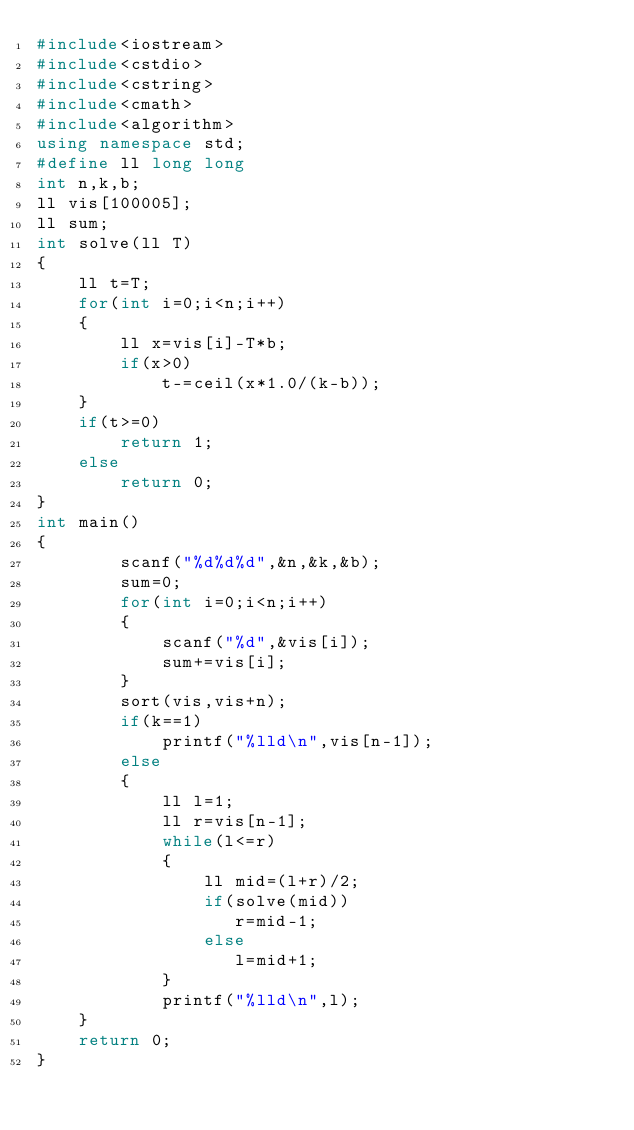Convert code to text. <code><loc_0><loc_0><loc_500><loc_500><_C++_>#include<iostream>
#include<cstdio>
#include<cstring>
#include<cmath>
#include<algorithm>
using namespace std;
#define ll long long
int n,k,b;
ll vis[100005];
ll sum;
int solve(ll T)
{
    ll t=T;
    for(int i=0;i<n;i++)
    {
        ll x=vis[i]-T*b;
        if(x>0)
            t-=ceil(x*1.0/(k-b));
    }
    if(t>=0)
        return 1;
    else
        return 0;
}
int main()
{
        scanf("%d%d%d",&n,&k,&b);
        sum=0;
        for(int i=0;i<n;i++)
        {
            scanf("%d",&vis[i]);
            sum+=vis[i];
        }
        sort(vis,vis+n);
        if(k==1)
            printf("%lld\n",vis[n-1]);
        else
        {
            ll l=1;
            ll r=vis[n-1];
            while(l<=r)
            {
                ll mid=(l+r)/2;
                if(solve(mid))
                   r=mid-1;
                else
                   l=mid+1;
            }
            printf("%lld\n",l);
    }
    return 0;
}
</code> 